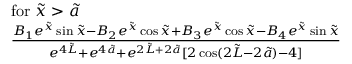<formula> <loc_0><loc_0><loc_500><loc_500>\begin{array} { r l } & { f o r \tilde { x } > \tilde { a } } \\ & { \frac { B _ { 1 } e ^ { \tilde { x } } \sin { \tilde { x } } - B _ { 2 } e ^ { \tilde { x } } \cos { \tilde { x } } + B _ { 3 } e ^ { \tilde { x } } \cos { \tilde { x } } - B _ { 4 } e ^ { \tilde { x } } \sin { \tilde { x } } } { e ^ { 4 \tilde { L } } + e ^ { 4 \tilde { a } } + e ^ { 2 \tilde { L } + 2 \tilde { a } } [ 2 \cos ( 2 \tilde { L } - 2 \tilde { a } ) - 4 ] } } \end{array}</formula> 